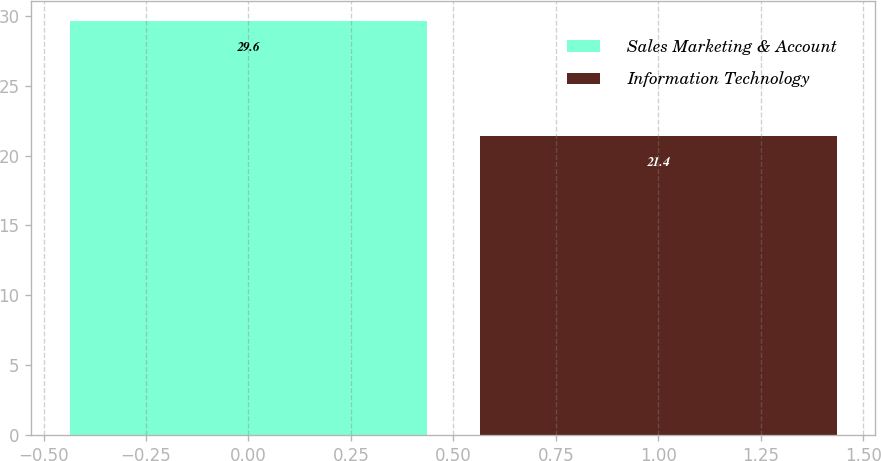Convert chart. <chart><loc_0><loc_0><loc_500><loc_500><bar_chart><fcel>Sales Marketing & Account<fcel>Information Technology<nl><fcel>29.6<fcel>21.4<nl></chart> 